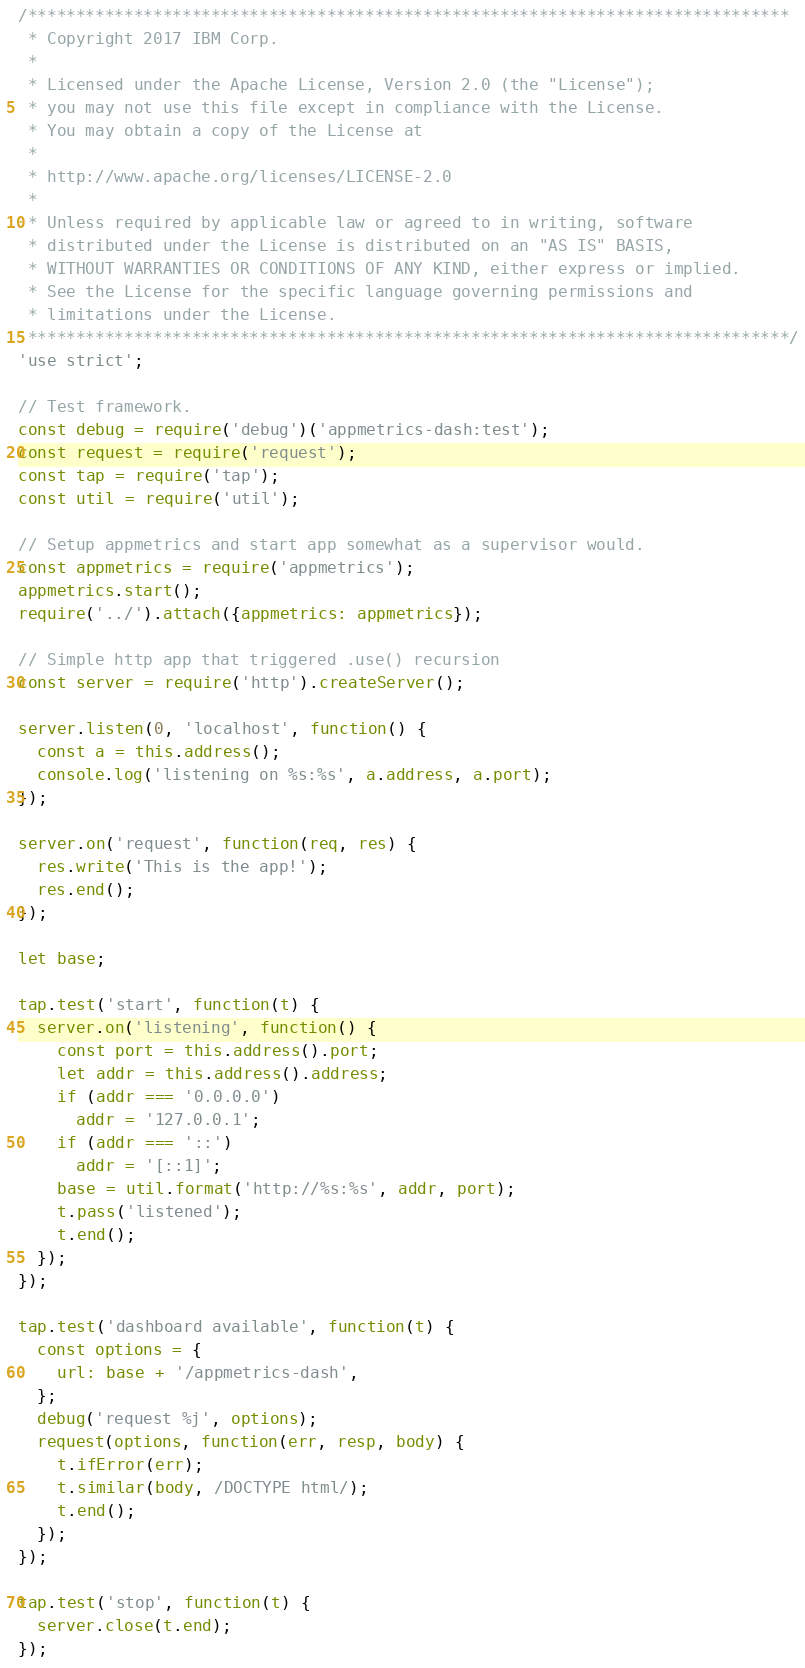<code> <loc_0><loc_0><loc_500><loc_500><_JavaScript_>/*******************************************************************************
 * Copyright 2017 IBM Corp.
 *
 * Licensed under the Apache License, Version 2.0 (the "License");
 * you may not use this file except in compliance with the License.
 * You may obtain a copy of the License at
 *
 * http://www.apache.org/licenses/LICENSE-2.0
 *
 * Unless required by applicable law or agreed to in writing, software
 * distributed under the License is distributed on an "AS IS" BASIS,
 * WITHOUT WARRANTIES OR CONDITIONS OF ANY KIND, either express or implied.
 * See the License for the specific language governing permissions and
 * limitations under the License.
 *******************************************************************************/
'use strict';

// Test framework.
const debug = require('debug')('appmetrics-dash:test');
const request = require('request');
const tap = require('tap');
const util = require('util');

// Setup appmetrics and start app somewhat as a supervisor would.
const appmetrics = require('appmetrics');
appmetrics.start();
require('../').attach({appmetrics: appmetrics});

// Simple http app that triggered .use() recursion
const server = require('http').createServer();

server.listen(0, 'localhost', function() {
  const a = this.address();
  console.log('listening on %s:%s', a.address, a.port);
});

server.on('request', function(req, res) {
  res.write('This is the app!');
  res.end();
});

let base;

tap.test('start', function(t) {
  server.on('listening', function() {
    const port = this.address().port;
    let addr = this.address().address;
    if (addr === '0.0.0.0')
      addr = '127.0.0.1';
    if (addr === '::')
      addr = '[::1]';
    base = util.format('http://%s:%s', addr, port);
    t.pass('listened');
    t.end();
  });
});

tap.test('dashboard available', function(t) {
  const options = {
    url: base + '/appmetrics-dash',
  };
  debug('request %j', options);
  request(options, function(err, resp, body) {
    t.ifError(err);
    t.similar(body, /DOCTYPE html/);
    t.end();
  });
});

tap.test('stop', function(t) {
  server.close(t.end);
});
</code> 